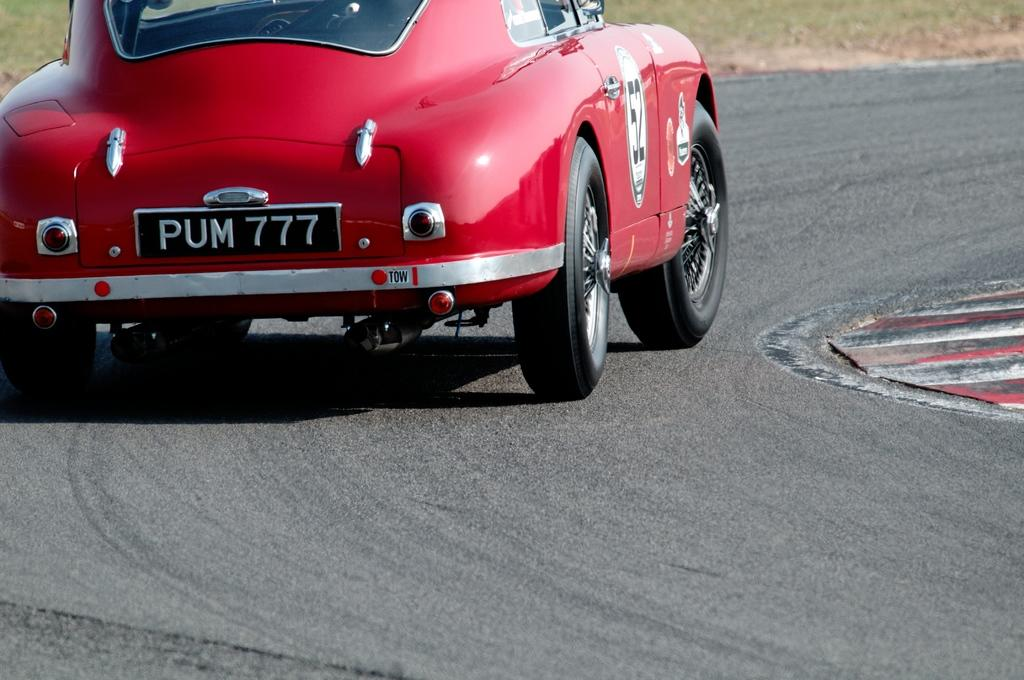What color is the car in the image? The car in the image is red. Where is the car located? The car is on the road. What can be seen behind the car? There is grass visible behind the car. Can you see the grandmother holding a rifle in the image? There is no grandmother or rifle present in the image. 